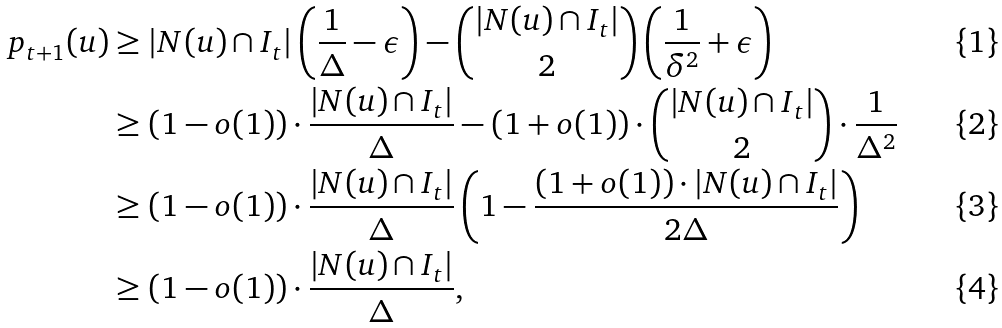<formula> <loc_0><loc_0><loc_500><loc_500>p _ { t + 1 } ( u ) & \geq | N ( u ) \cap I _ { t } | \left ( \frac { 1 } { \Delta } - \epsilon \right ) - { | N ( u ) \cap I _ { t } | \choose 2 } \left ( \frac { 1 } { \delta ^ { 2 } } + \epsilon \right ) \\ & \geq ( 1 - o ( 1 ) ) \cdot \frac { | N ( u ) \cap I _ { t } | } { \Delta } - ( 1 + o ( 1 ) ) \cdot { | N ( u ) \cap I _ { t } | \choose 2 } \cdot \frac { 1 } { \Delta ^ { 2 } } \\ & \geq ( 1 - o ( 1 ) ) \cdot \frac { | N ( u ) \cap I _ { t } | } { \Delta } \left ( 1 - \frac { ( 1 + o ( 1 ) ) \cdot | N ( u ) \cap I _ { t } | } { 2 \Delta } \right ) \\ & \geq ( 1 - o ( 1 ) ) \cdot \frac { | N ( u ) \cap I _ { t } | } { \Delta } ,</formula> 